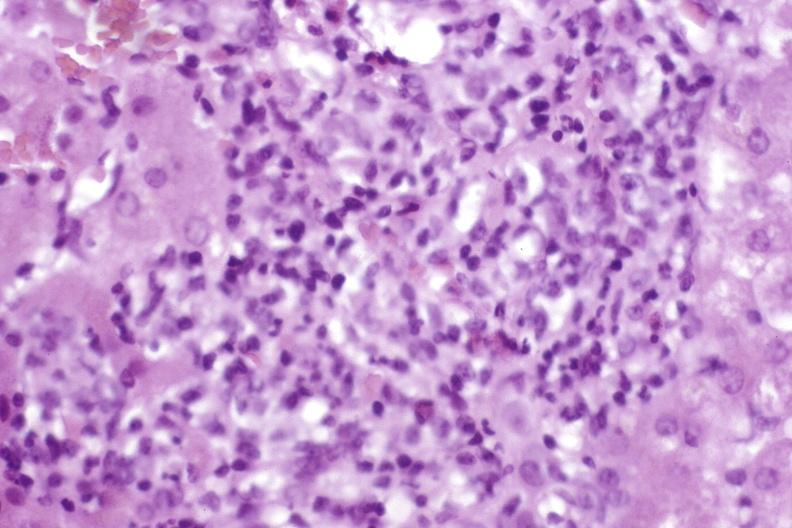what does this image show?
Answer the question using a single word or phrase. Moderate acute rejection 